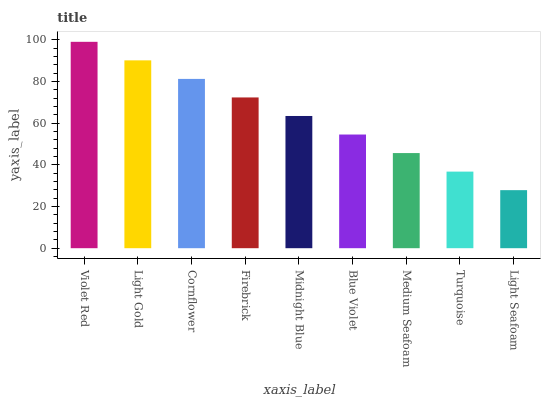Is Light Seafoam the minimum?
Answer yes or no. Yes. Is Violet Red the maximum?
Answer yes or no. Yes. Is Light Gold the minimum?
Answer yes or no. No. Is Light Gold the maximum?
Answer yes or no. No. Is Violet Red greater than Light Gold?
Answer yes or no. Yes. Is Light Gold less than Violet Red?
Answer yes or no. Yes. Is Light Gold greater than Violet Red?
Answer yes or no. No. Is Violet Red less than Light Gold?
Answer yes or no. No. Is Midnight Blue the high median?
Answer yes or no. Yes. Is Midnight Blue the low median?
Answer yes or no. Yes. Is Cornflower the high median?
Answer yes or no. No. Is Medium Seafoam the low median?
Answer yes or no. No. 